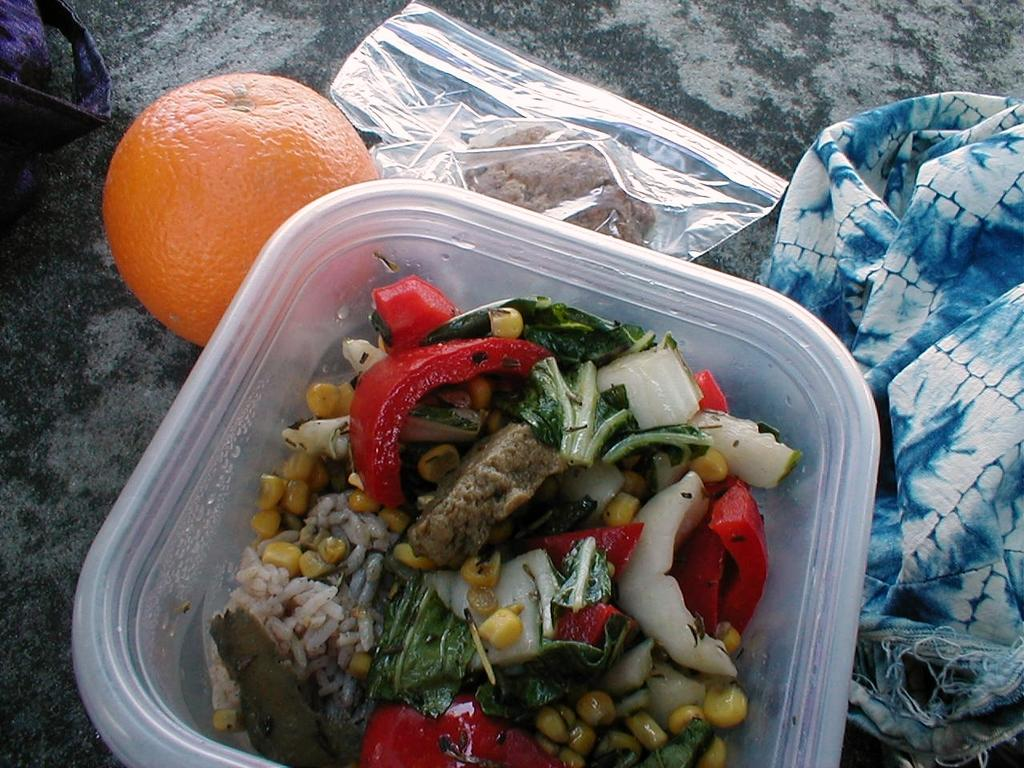What is in the bowl that is visible in the image? There is a bowl with food in the image. Can you describe the appearance of the food? The food is colorful. What fruit can be seen in the image? There is an orange in the image. What type of covering is present in the image? There is a plastic cover in the image. What color and pattern is the cloth in the image? The cloth is blue and white in color. On what surface are the objects placed in the image? The objects are on a grey color surface. What type of trousers is the food wearing in the image? The food is not wearing any trousers, as it is an inanimate object and not capable of wearing clothing. 